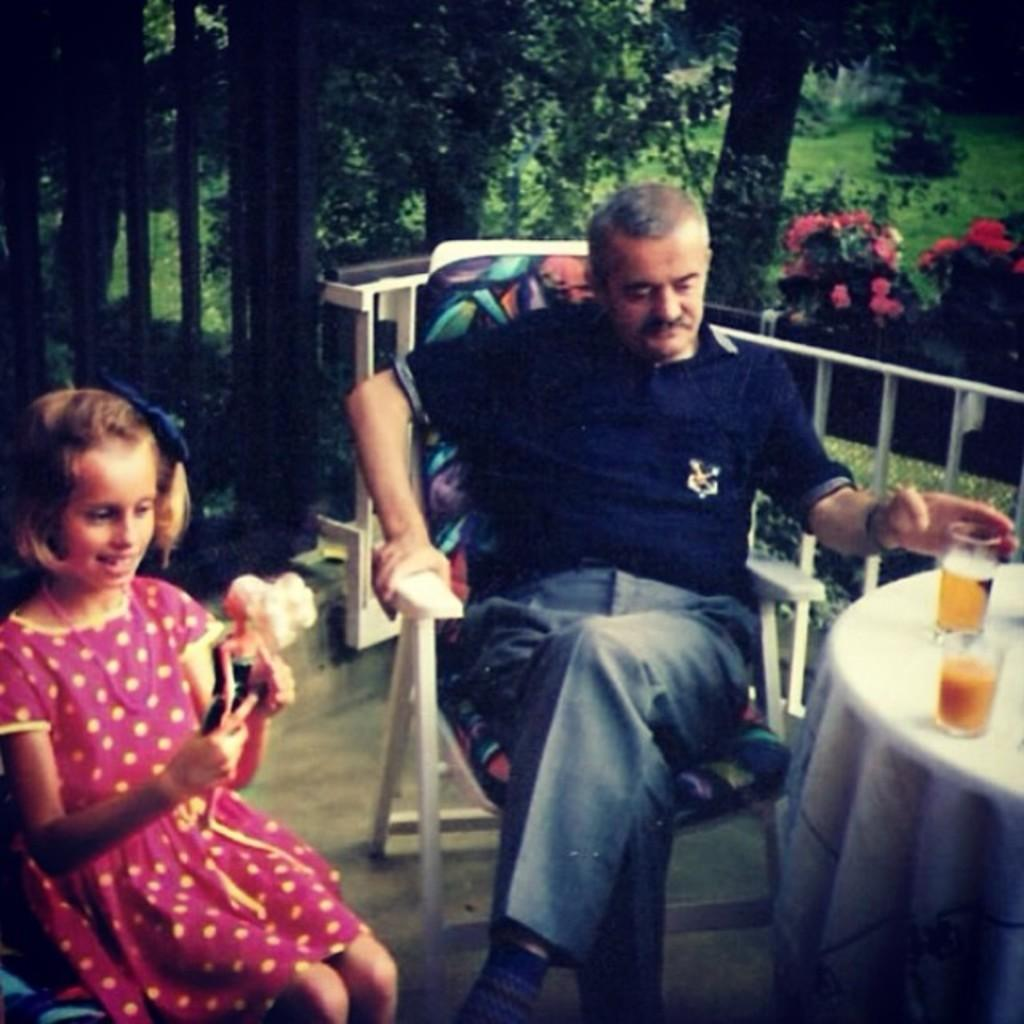Who are the people in the image? There is a man and a girl in the image. What are the man and the girl doing in the image? Both the man and the girl are seated on chairs. What objects can be seen on the table in the image? There are two glasses on a table. What can be seen in the background of the image? There are trees visible in the image. What is the interest of the dogs in the image? There are no dogs present in the image. 